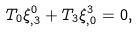Convert formula to latex. <formula><loc_0><loc_0><loc_500><loc_500>T _ { 0 } \xi ^ { 0 } _ { , 3 } + T _ { 3 } \xi ^ { 3 } _ { , 0 } = 0 ,</formula> 